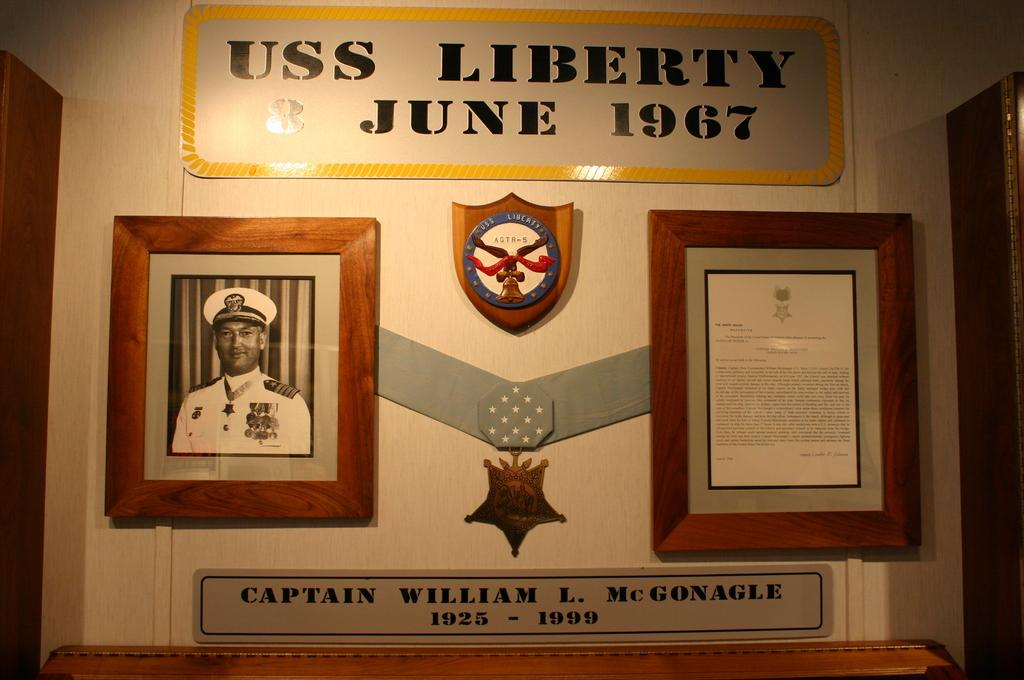<image>
Create a compact narrative representing the image presented. Wall with the words USS Liberty and a picture of a man under. 